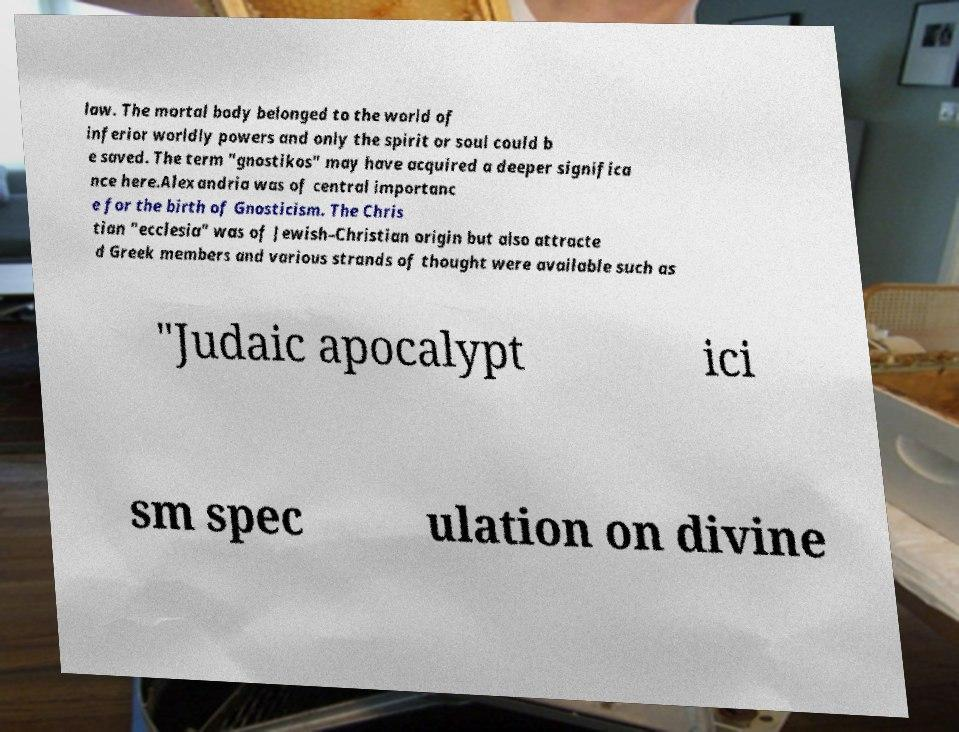What messages or text are displayed in this image? I need them in a readable, typed format. law. The mortal body belonged to the world of inferior worldly powers and only the spirit or soul could b e saved. The term "gnostikos" may have acquired a deeper significa nce here.Alexandria was of central importanc e for the birth of Gnosticism. The Chris tian "ecclesia" was of Jewish–Christian origin but also attracte d Greek members and various strands of thought were available such as "Judaic apocalypt ici sm spec ulation on divine 